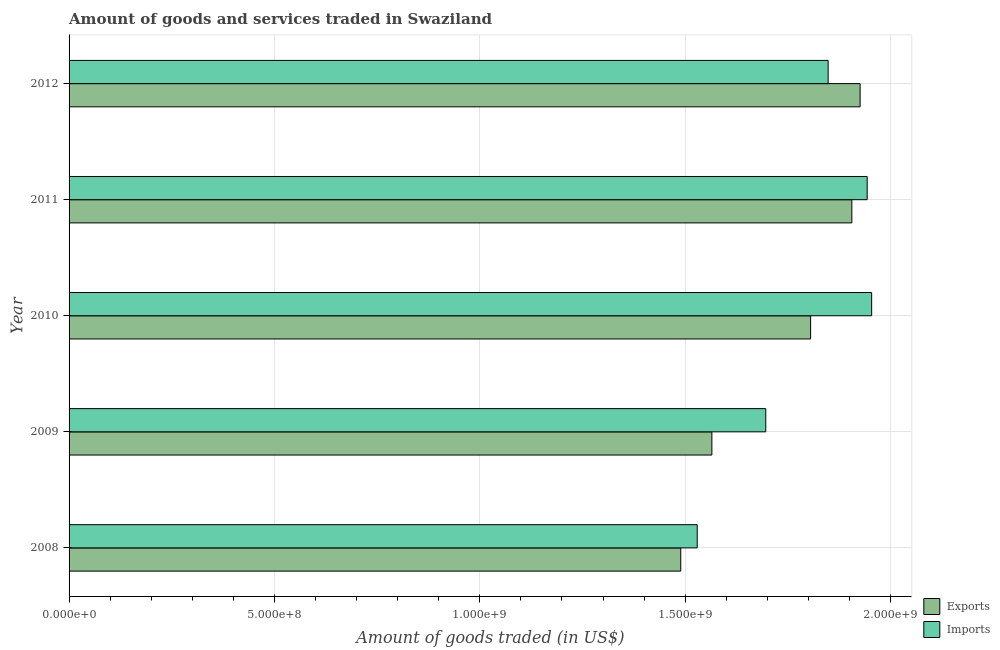Are the number of bars per tick equal to the number of legend labels?
Your response must be concise. Yes. Are the number of bars on each tick of the Y-axis equal?
Make the answer very short. Yes. In how many cases, is the number of bars for a given year not equal to the number of legend labels?
Offer a terse response. 0. What is the amount of goods imported in 2009?
Make the answer very short. 1.70e+09. Across all years, what is the maximum amount of goods imported?
Your response must be concise. 1.95e+09. Across all years, what is the minimum amount of goods imported?
Offer a very short reply. 1.53e+09. In which year was the amount of goods imported maximum?
Ensure brevity in your answer.  2010. In which year was the amount of goods exported minimum?
Your response must be concise. 2008. What is the total amount of goods exported in the graph?
Your answer should be very brief. 8.69e+09. What is the difference between the amount of goods imported in 2009 and that in 2010?
Provide a succinct answer. -2.58e+08. What is the difference between the amount of goods imported in 2009 and the amount of goods exported in 2011?
Provide a succinct answer. -2.10e+08. What is the average amount of goods exported per year?
Give a very brief answer. 1.74e+09. In the year 2011, what is the difference between the amount of goods imported and amount of goods exported?
Your answer should be compact. 3.73e+07. In how many years, is the amount of goods imported greater than 1500000000 US$?
Your answer should be very brief. 5. What is the ratio of the amount of goods exported in 2008 to that in 2012?
Your answer should be compact. 0.77. Is the difference between the amount of goods imported in 2010 and 2012 greater than the difference between the amount of goods exported in 2010 and 2012?
Offer a terse response. Yes. What is the difference between the highest and the second highest amount of goods imported?
Ensure brevity in your answer.  1.09e+07. What is the difference between the highest and the lowest amount of goods imported?
Ensure brevity in your answer.  4.25e+08. In how many years, is the amount of goods exported greater than the average amount of goods exported taken over all years?
Your answer should be compact. 3. What does the 1st bar from the top in 2008 represents?
Offer a terse response. Imports. What does the 2nd bar from the bottom in 2010 represents?
Provide a short and direct response. Imports. What is the difference between two consecutive major ticks on the X-axis?
Your response must be concise. 5.00e+08. Are the values on the major ticks of X-axis written in scientific E-notation?
Your answer should be compact. Yes. Does the graph contain any zero values?
Give a very brief answer. No. Where does the legend appear in the graph?
Your answer should be compact. Bottom right. How are the legend labels stacked?
Offer a terse response. Vertical. What is the title of the graph?
Offer a terse response. Amount of goods and services traded in Swaziland. What is the label or title of the X-axis?
Your answer should be very brief. Amount of goods traded (in US$). What is the label or title of the Y-axis?
Your response must be concise. Year. What is the Amount of goods traded (in US$) in Exports in 2008?
Provide a succinct answer. 1.49e+09. What is the Amount of goods traded (in US$) of Imports in 2008?
Offer a terse response. 1.53e+09. What is the Amount of goods traded (in US$) in Exports in 2009?
Make the answer very short. 1.56e+09. What is the Amount of goods traded (in US$) in Imports in 2009?
Make the answer very short. 1.70e+09. What is the Amount of goods traded (in US$) of Exports in 2010?
Offer a very short reply. 1.81e+09. What is the Amount of goods traded (in US$) in Imports in 2010?
Provide a short and direct response. 1.95e+09. What is the Amount of goods traded (in US$) in Exports in 2011?
Offer a terse response. 1.91e+09. What is the Amount of goods traded (in US$) in Imports in 2011?
Make the answer very short. 1.94e+09. What is the Amount of goods traded (in US$) in Exports in 2012?
Ensure brevity in your answer.  1.93e+09. What is the Amount of goods traded (in US$) of Imports in 2012?
Your answer should be very brief. 1.85e+09. Across all years, what is the maximum Amount of goods traded (in US$) in Exports?
Offer a very short reply. 1.93e+09. Across all years, what is the maximum Amount of goods traded (in US$) of Imports?
Offer a terse response. 1.95e+09. Across all years, what is the minimum Amount of goods traded (in US$) in Exports?
Your answer should be compact. 1.49e+09. Across all years, what is the minimum Amount of goods traded (in US$) in Imports?
Your answer should be compact. 1.53e+09. What is the total Amount of goods traded (in US$) of Exports in the graph?
Ensure brevity in your answer.  8.69e+09. What is the total Amount of goods traded (in US$) of Imports in the graph?
Ensure brevity in your answer.  8.97e+09. What is the difference between the Amount of goods traded (in US$) in Exports in 2008 and that in 2009?
Your answer should be compact. -7.58e+07. What is the difference between the Amount of goods traded (in US$) in Imports in 2008 and that in 2009?
Give a very brief answer. -1.67e+08. What is the difference between the Amount of goods traded (in US$) in Exports in 2008 and that in 2010?
Make the answer very short. -3.16e+08. What is the difference between the Amount of goods traded (in US$) in Imports in 2008 and that in 2010?
Ensure brevity in your answer.  -4.25e+08. What is the difference between the Amount of goods traded (in US$) of Exports in 2008 and that in 2011?
Your answer should be very brief. -4.17e+08. What is the difference between the Amount of goods traded (in US$) in Imports in 2008 and that in 2011?
Keep it short and to the point. -4.14e+08. What is the difference between the Amount of goods traded (in US$) in Exports in 2008 and that in 2012?
Your response must be concise. -4.37e+08. What is the difference between the Amount of goods traded (in US$) of Imports in 2008 and that in 2012?
Offer a terse response. -3.19e+08. What is the difference between the Amount of goods traded (in US$) in Exports in 2009 and that in 2010?
Your answer should be compact. -2.40e+08. What is the difference between the Amount of goods traded (in US$) of Imports in 2009 and that in 2010?
Your response must be concise. -2.58e+08. What is the difference between the Amount of goods traded (in US$) in Exports in 2009 and that in 2011?
Offer a terse response. -3.41e+08. What is the difference between the Amount of goods traded (in US$) of Imports in 2009 and that in 2011?
Your answer should be compact. -2.47e+08. What is the difference between the Amount of goods traded (in US$) of Exports in 2009 and that in 2012?
Your response must be concise. -3.61e+08. What is the difference between the Amount of goods traded (in US$) of Imports in 2009 and that in 2012?
Ensure brevity in your answer.  -1.52e+08. What is the difference between the Amount of goods traded (in US$) of Exports in 2010 and that in 2011?
Your answer should be compact. -1.00e+08. What is the difference between the Amount of goods traded (in US$) in Imports in 2010 and that in 2011?
Keep it short and to the point. 1.09e+07. What is the difference between the Amount of goods traded (in US$) in Exports in 2010 and that in 2012?
Offer a terse response. -1.21e+08. What is the difference between the Amount of goods traded (in US$) in Imports in 2010 and that in 2012?
Provide a short and direct response. 1.06e+08. What is the difference between the Amount of goods traded (in US$) in Exports in 2011 and that in 2012?
Offer a very short reply. -2.02e+07. What is the difference between the Amount of goods traded (in US$) in Imports in 2011 and that in 2012?
Your response must be concise. 9.50e+07. What is the difference between the Amount of goods traded (in US$) of Exports in 2008 and the Amount of goods traded (in US$) of Imports in 2009?
Ensure brevity in your answer.  -2.07e+08. What is the difference between the Amount of goods traded (in US$) in Exports in 2008 and the Amount of goods traded (in US$) in Imports in 2010?
Provide a succinct answer. -4.65e+08. What is the difference between the Amount of goods traded (in US$) of Exports in 2008 and the Amount of goods traded (in US$) of Imports in 2011?
Provide a succinct answer. -4.54e+08. What is the difference between the Amount of goods traded (in US$) in Exports in 2008 and the Amount of goods traded (in US$) in Imports in 2012?
Your response must be concise. -3.59e+08. What is the difference between the Amount of goods traded (in US$) in Exports in 2009 and the Amount of goods traded (in US$) in Imports in 2010?
Your response must be concise. -3.89e+08. What is the difference between the Amount of goods traded (in US$) of Exports in 2009 and the Amount of goods traded (in US$) of Imports in 2011?
Give a very brief answer. -3.78e+08. What is the difference between the Amount of goods traded (in US$) in Exports in 2009 and the Amount of goods traded (in US$) in Imports in 2012?
Offer a terse response. -2.83e+08. What is the difference between the Amount of goods traded (in US$) of Exports in 2010 and the Amount of goods traded (in US$) of Imports in 2011?
Your response must be concise. -1.38e+08. What is the difference between the Amount of goods traded (in US$) in Exports in 2010 and the Amount of goods traded (in US$) in Imports in 2012?
Offer a terse response. -4.27e+07. What is the difference between the Amount of goods traded (in US$) of Exports in 2011 and the Amount of goods traded (in US$) of Imports in 2012?
Your answer should be compact. 5.77e+07. What is the average Amount of goods traded (in US$) in Exports per year?
Offer a very short reply. 1.74e+09. What is the average Amount of goods traded (in US$) of Imports per year?
Keep it short and to the point. 1.79e+09. In the year 2008, what is the difference between the Amount of goods traded (in US$) of Exports and Amount of goods traded (in US$) of Imports?
Provide a short and direct response. -4.01e+07. In the year 2009, what is the difference between the Amount of goods traded (in US$) of Exports and Amount of goods traded (in US$) of Imports?
Offer a terse response. -1.31e+08. In the year 2010, what is the difference between the Amount of goods traded (in US$) of Exports and Amount of goods traded (in US$) of Imports?
Make the answer very short. -1.49e+08. In the year 2011, what is the difference between the Amount of goods traded (in US$) in Exports and Amount of goods traded (in US$) in Imports?
Provide a short and direct response. -3.73e+07. In the year 2012, what is the difference between the Amount of goods traded (in US$) in Exports and Amount of goods traded (in US$) in Imports?
Give a very brief answer. 7.79e+07. What is the ratio of the Amount of goods traded (in US$) of Exports in 2008 to that in 2009?
Offer a terse response. 0.95. What is the ratio of the Amount of goods traded (in US$) of Imports in 2008 to that in 2009?
Your response must be concise. 0.9. What is the ratio of the Amount of goods traded (in US$) of Exports in 2008 to that in 2010?
Your response must be concise. 0.82. What is the ratio of the Amount of goods traded (in US$) in Imports in 2008 to that in 2010?
Provide a succinct answer. 0.78. What is the ratio of the Amount of goods traded (in US$) in Exports in 2008 to that in 2011?
Make the answer very short. 0.78. What is the ratio of the Amount of goods traded (in US$) of Imports in 2008 to that in 2011?
Your answer should be compact. 0.79. What is the ratio of the Amount of goods traded (in US$) of Exports in 2008 to that in 2012?
Offer a terse response. 0.77. What is the ratio of the Amount of goods traded (in US$) of Imports in 2008 to that in 2012?
Provide a short and direct response. 0.83. What is the ratio of the Amount of goods traded (in US$) in Exports in 2009 to that in 2010?
Offer a very short reply. 0.87. What is the ratio of the Amount of goods traded (in US$) of Imports in 2009 to that in 2010?
Keep it short and to the point. 0.87. What is the ratio of the Amount of goods traded (in US$) in Exports in 2009 to that in 2011?
Your answer should be very brief. 0.82. What is the ratio of the Amount of goods traded (in US$) of Imports in 2009 to that in 2011?
Make the answer very short. 0.87. What is the ratio of the Amount of goods traded (in US$) in Exports in 2009 to that in 2012?
Ensure brevity in your answer.  0.81. What is the ratio of the Amount of goods traded (in US$) in Imports in 2009 to that in 2012?
Provide a succinct answer. 0.92. What is the ratio of the Amount of goods traded (in US$) in Exports in 2010 to that in 2011?
Offer a terse response. 0.95. What is the ratio of the Amount of goods traded (in US$) in Imports in 2010 to that in 2011?
Provide a succinct answer. 1.01. What is the ratio of the Amount of goods traded (in US$) of Exports in 2010 to that in 2012?
Your answer should be compact. 0.94. What is the ratio of the Amount of goods traded (in US$) in Imports in 2010 to that in 2012?
Keep it short and to the point. 1.06. What is the ratio of the Amount of goods traded (in US$) of Imports in 2011 to that in 2012?
Keep it short and to the point. 1.05. What is the difference between the highest and the second highest Amount of goods traded (in US$) of Exports?
Make the answer very short. 2.02e+07. What is the difference between the highest and the second highest Amount of goods traded (in US$) in Imports?
Provide a short and direct response. 1.09e+07. What is the difference between the highest and the lowest Amount of goods traded (in US$) in Exports?
Keep it short and to the point. 4.37e+08. What is the difference between the highest and the lowest Amount of goods traded (in US$) of Imports?
Ensure brevity in your answer.  4.25e+08. 